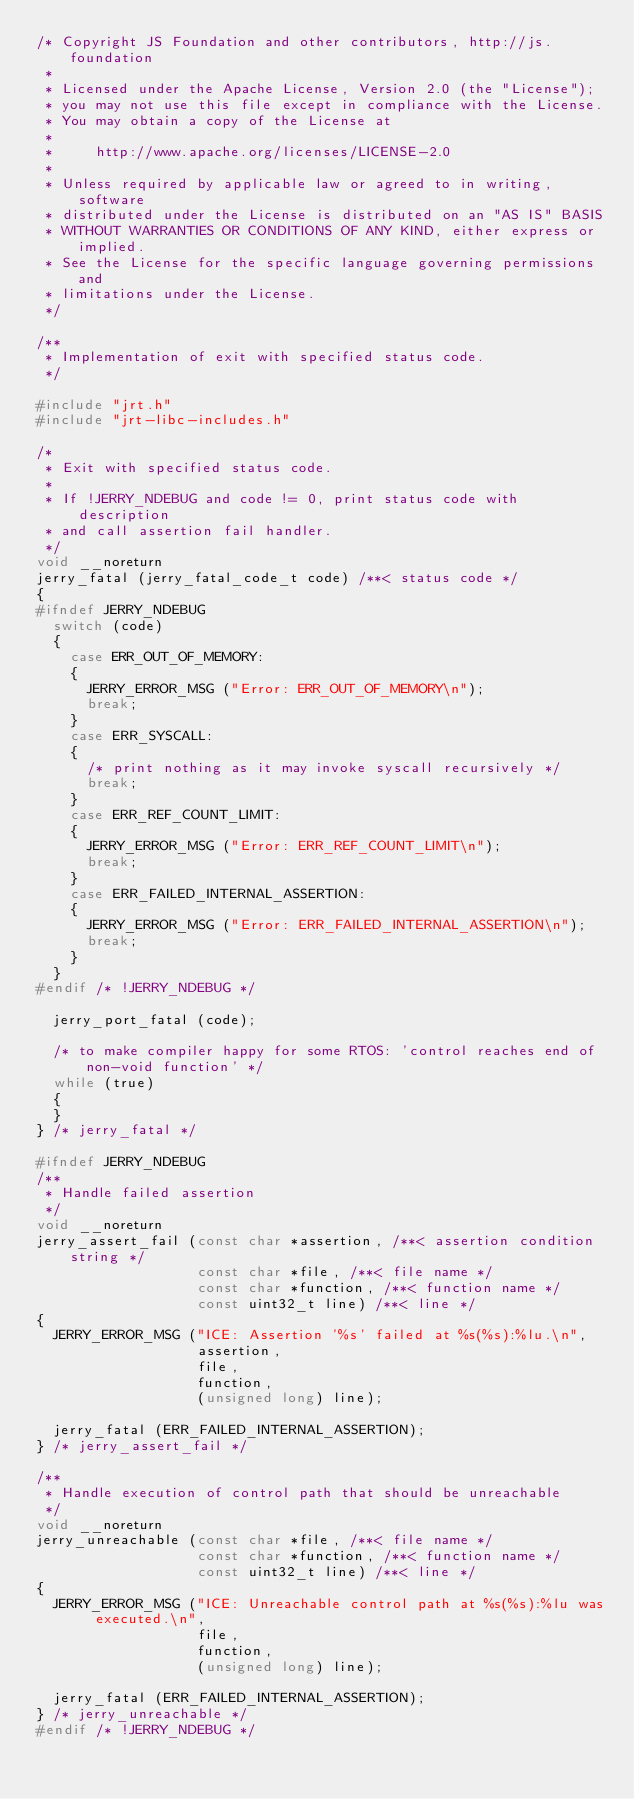Convert code to text. <code><loc_0><loc_0><loc_500><loc_500><_C_>/* Copyright JS Foundation and other contributors, http://js.foundation
 *
 * Licensed under the Apache License, Version 2.0 (the "License");
 * you may not use this file except in compliance with the License.
 * You may obtain a copy of the License at
 *
 *     http://www.apache.org/licenses/LICENSE-2.0
 *
 * Unless required by applicable law or agreed to in writing, software
 * distributed under the License is distributed on an "AS IS" BASIS
 * WITHOUT WARRANTIES OR CONDITIONS OF ANY KIND, either express or implied.
 * See the License for the specific language governing permissions and
 * limitations under the License.
 */

/**
 * Implementation of exit with specified status code.
 */

#include "jrt.h"
#include "jrt-libc-includes.h"

/*
 * Exit with specified status code.
 *
 * If !JERRY_NDEBUG and code != 0, print status code with description
 * and call assertion fail handler.
 */
void __noreturn
jerry_fatal (jerry_fatal_code_t code) /**< status code */
{
#ifndef JERRY_NDEBUG
  switch (code)
  {
    case ERR_OUT_OF_MEMORY:
    {
      JERRY_ERROR_MSG ("Error: ERR_OUT_OF_MEMORY\n");
      break;
    }
    case ERR_SYSCALL:
    {
      /* print nothing as it may invoke syscall recursively */
      break;
    }
    case ERR_REF_COUNT_LIMIT:
    {
      JERRY_ERROR_MSG ("Error: ERR_REF_COUNT_LIMIT\n");
      break;
    }
    case ERR_FAILED_INTERNAL_ASSERTION:
    {
      JERRY_ERROR_MSG ("Error: ERR_FAILED_INTERNAL_ASSERTION\n");
      break;
    }
  }
#endif /* !JERRY_NDEBUG */

  jerry_port_fatal (code);

  /* to make compiler happy for some RTOS: 'control reaches end of non-void function' */
  while (true)
  {
  }
} /* jerry_fatal */

#ifndef JERRY_NDEBUG
/**
 * Handle failed assertion
 */
void __noreturn
jerry_assert_fail (const char *assertion, /**< assertion condition string */
                   const char *file, /**< file name */
                   const char *function, /**< function name */
                   const uint32_t line) /**< line */
{
  JERRY_ERROR_MSG ("ICE: Assertion '%s' failed at %s(%s):%lu.\n",
                   assertion,
                   file,
                   function,
                   (unsigned long) line);

  jerry_fatal (ERR_FAILED_INTERNAL_ASSERTION);
} /* jerry_assert_fail */

/**
 * Handle execution of control path that should be unreachable
 */
void __noreturn
jerry_unreachable (const char *file, /**< file name */
                   const char *function, /**< function name */
                   const uint32_t line) /**< line */
{
  JERRY_ERROR_MSG ("ICE: Unreachable control path at %s(%s):%lu was executed.\n",
                   file,
                   function,
                   (unsigned long) line);

  jerry_fatal (ERR_FAILED_INTERNAL_ASSERTION);
} /* jerry_unreachable */
#endif /* !JERRY_NDEBUG */
</code> 